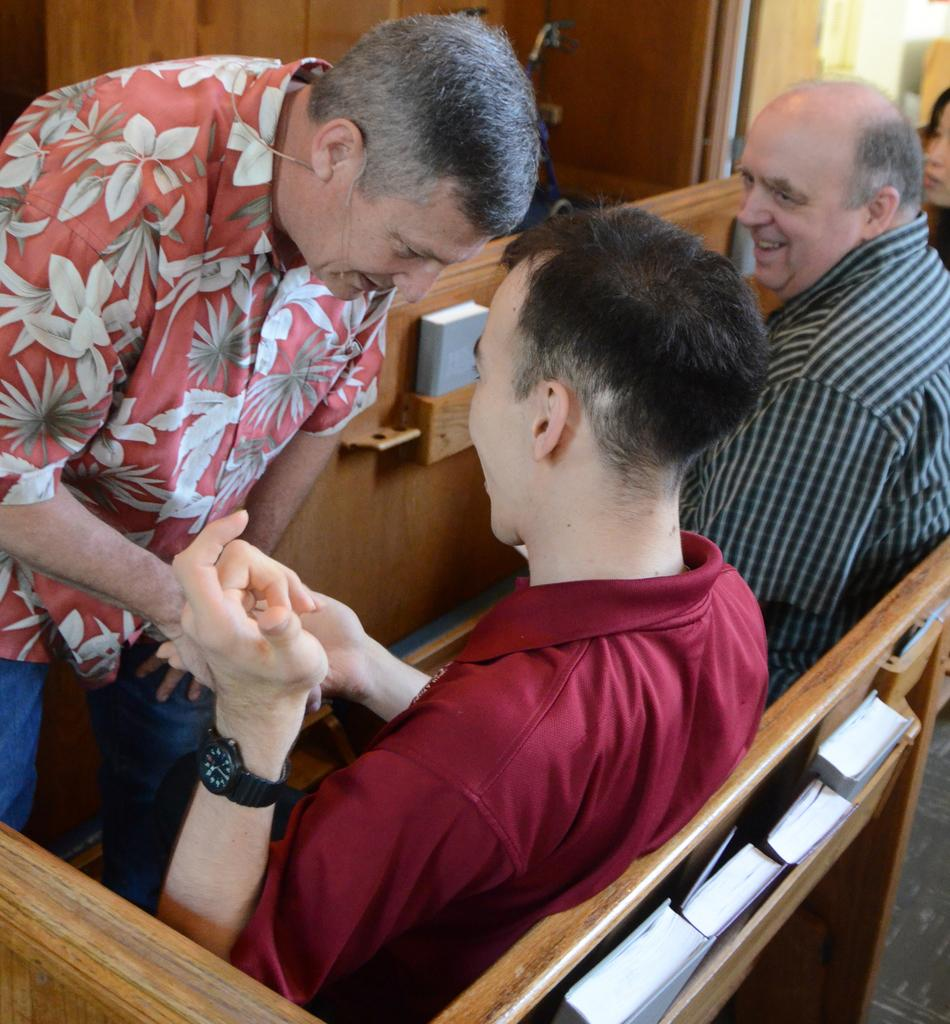What is the position of the person in the image? There is a person standing on the left side of the image. How many persons are sitting in the image? Two persons are sitting on benches in the image. What is located near the bench? There is a rack near the bench. What items can be found inside the rack? Books are present inside the rack. Can you see a crown on the person's head in the image? No, there is no crown visible on anyone's head in the image. 